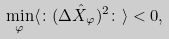Convert formula to latex. <formula><loc_0><loc_0><loc_500><loc_500>\min _ { \varphi } \langle \colon ( \Delta \hat { X } _ { \varphi } ) ^ { 2 } \colon \rangle < 0 ,</formula> 